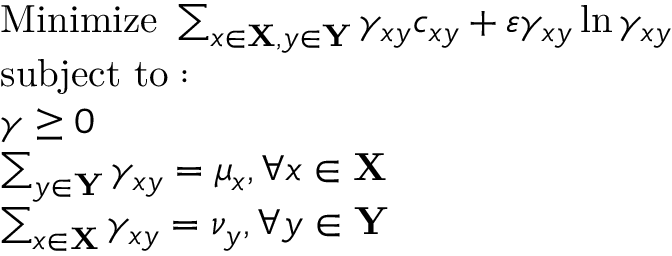Convert formula to latex. <formula><loc_0><loc_0><loc_500><loc_500>{ \begin{array} { r l } & { { M i n i m i z e } \sum _ { x \in X , y \in Y } \gamma _ { x y } c _ { x y } + \varepsilon \gamma _ { x y } \ln \gamma _ { x y } } \\ & { s u b j e c t t o \colon } \\ & { \gamma \geq 0 } \\ & { \sum _ { y \in Y } \gamma _ { x y } = \mu _ { x } , \forall x \in X } \\ & { \sum _ { x \in X } \gamma _ { x y } = \nu _ { y } , \forall y \in Y } \end{array} }</formula> 